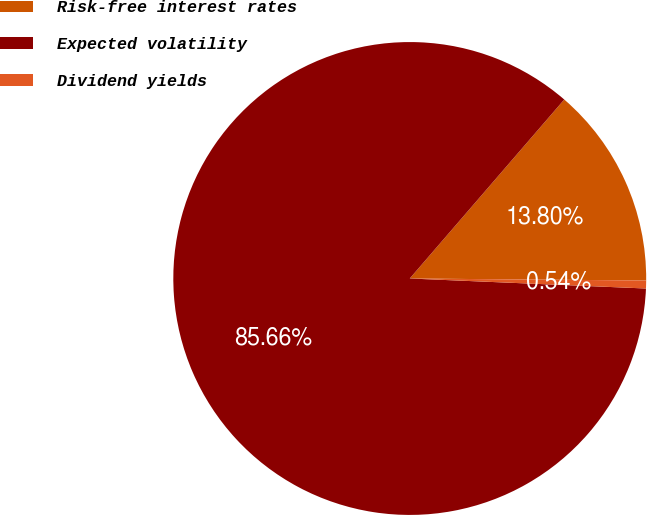<chart> <loc_0><loc_0><loc_500><loc_500><pie_chart><fcel>Risk-free interest rates<fcel>Expected volatility<fcel>Dividend yields<nl><fcel>13.8%<fcel>85.66%<fcel>0.54%<nl></chart> 